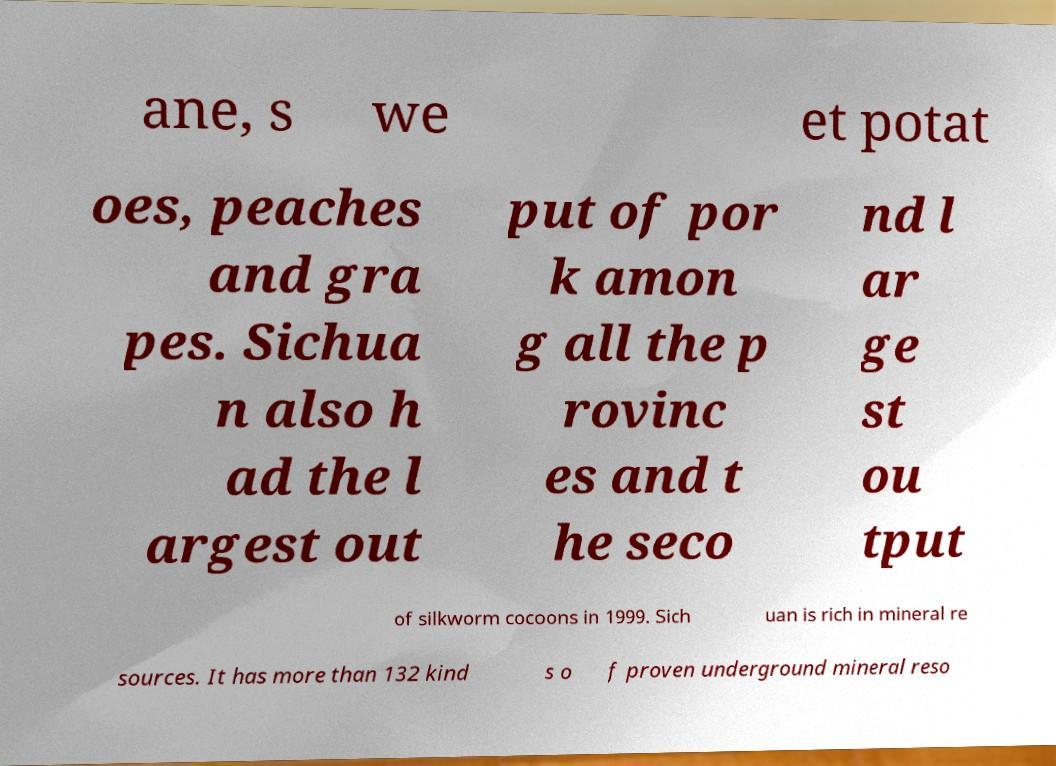Please read and relay the text visible in this image. What does it say? ane, s we et potat oes, peaches and gra pes. Sichua n also h ad the l argest out put of por k amon g all the p rovinc es and t he seco nd l ar ge st ou tput of silkworm cocoons in 1999. Sich uan is rich in mineral re sources. It has more than 132 kind s o f proven underground mineral reso 